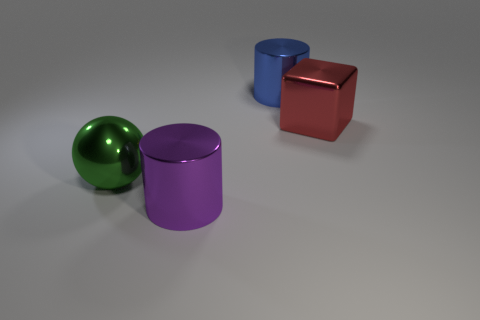What material is the cylinder in front of the large object that is on the right side of the blue cylinder?
Your answer should be very brief. Metal. There is a blue cylinder that is the same size as the shiny block; what material is it?
Provide a short and direct response. Metal. What number of tiny objects are either cyan things or purple cylinders?
Keep it short and to the point. 0. Is the shape of the big purple shiny object the same as the blue object?
Offer a terse response. Yes. How many large metal things are both in front of the ball and behind the red cube?
Provide a succinct answer. 0. There is a large blue thing that is the same material as the purple thing; what is its shape?
Keep it short and to the point. Cylinder. There is a cylinder to the left of the big cylinder behind the red shiny thing; what number of big metal cylinders are behind it?
Provide a short and direct response. 1. There is a large shiny object that is behind the big red object; is its shape the same as the large purple metal thing?
Provide a succinct answer. Yes. What number of objects are either blue matte cubes or cylinders that are behind the red metal block?
Make the answer very short. 1. Are there more things that are behind the metal ball than shiny blocks?
Offer a very short reply. Yes. 